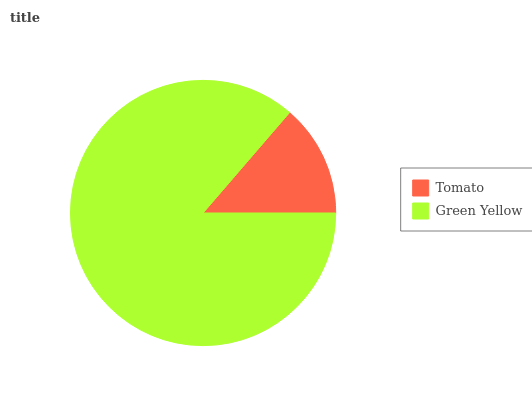Is Tomato the minimum?
Answer yes or no. Yes. Is Green Yellow the maximum?
Answer yes or no. Yes. Is Green Yellow the minimum?
Answer yes or no. No. Is Green Yellow greater than Tomato?
Answer yes or no. Yes. Is Tomato less than Green Yellow?
Answer yes or no. Yes. Is Tomato greater than Green Yellow?
Answer yes or no. No. Is Green Yellow less than Tomato?
Answer yes or no. No. Is Green Yellow the high median?
Answer yes or no. Yes. Is Tomato the low median?
Answer yes or no. Yes. Is Tomato the high median?
Answer yes or no. No. Is Green Yellow the low median?
Answer yes or no. No. 